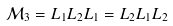Convert formula to latex. <formula><loc_0><loc_0><loc_500><loc_500>\mathcal { M } _ { 3 } = L _ { 1 } L _ { 2 } L _ { 1 } = L _ { 2 } L _ { 1 } L _ { 2 }</formula> 